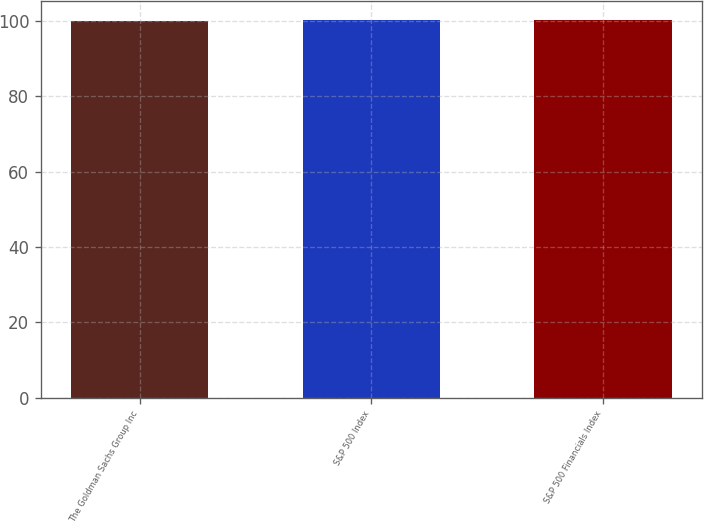Convert chart to OTSL. <chart><loc_0><loc_0><loc_500><loc_500><bar_chart><fcel>The Goldman Sachs Group Inc<fcel>S&P 500 Index<fcel>S&P 500 Financials Index<nl><fcel>100<fcel>100.1<fcel>100.2<nl></chart> 